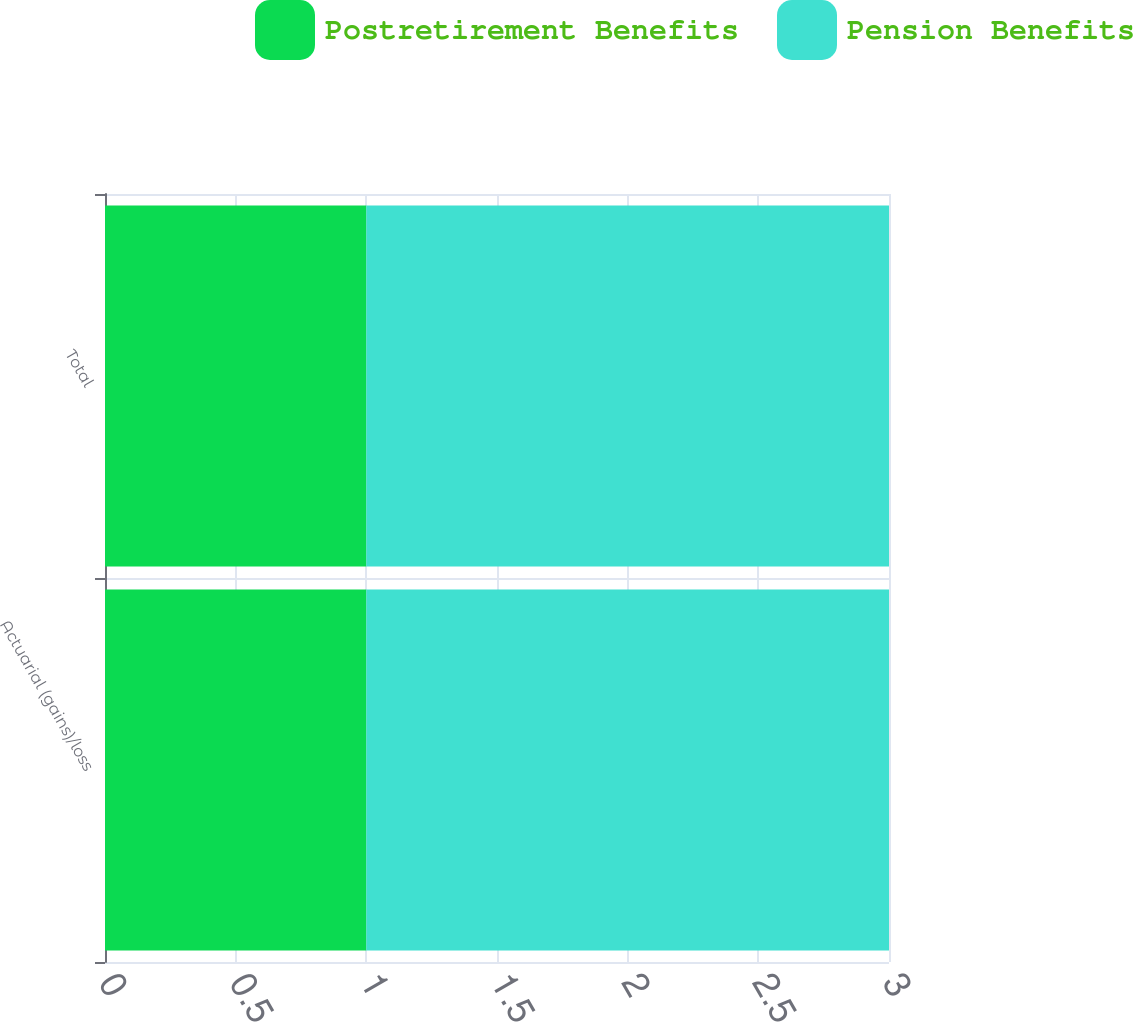Convert chart to OTSL. <chart><loc_0><loc_0><loc_500><loc_500><stacked_bar_chart><ecel><fcel>Actuarial (gains)/loss<fcel>Total<nl><fcel>Postretirement Benefits<fcel>1<fcel>1<nl><fcel>Pension Benefits<fcel>2<fcel>2<nl></chart> 